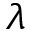Convert formula to latex. <formula><loc_0><loc_0><loc_500><loc_500>\lambda</formula> 